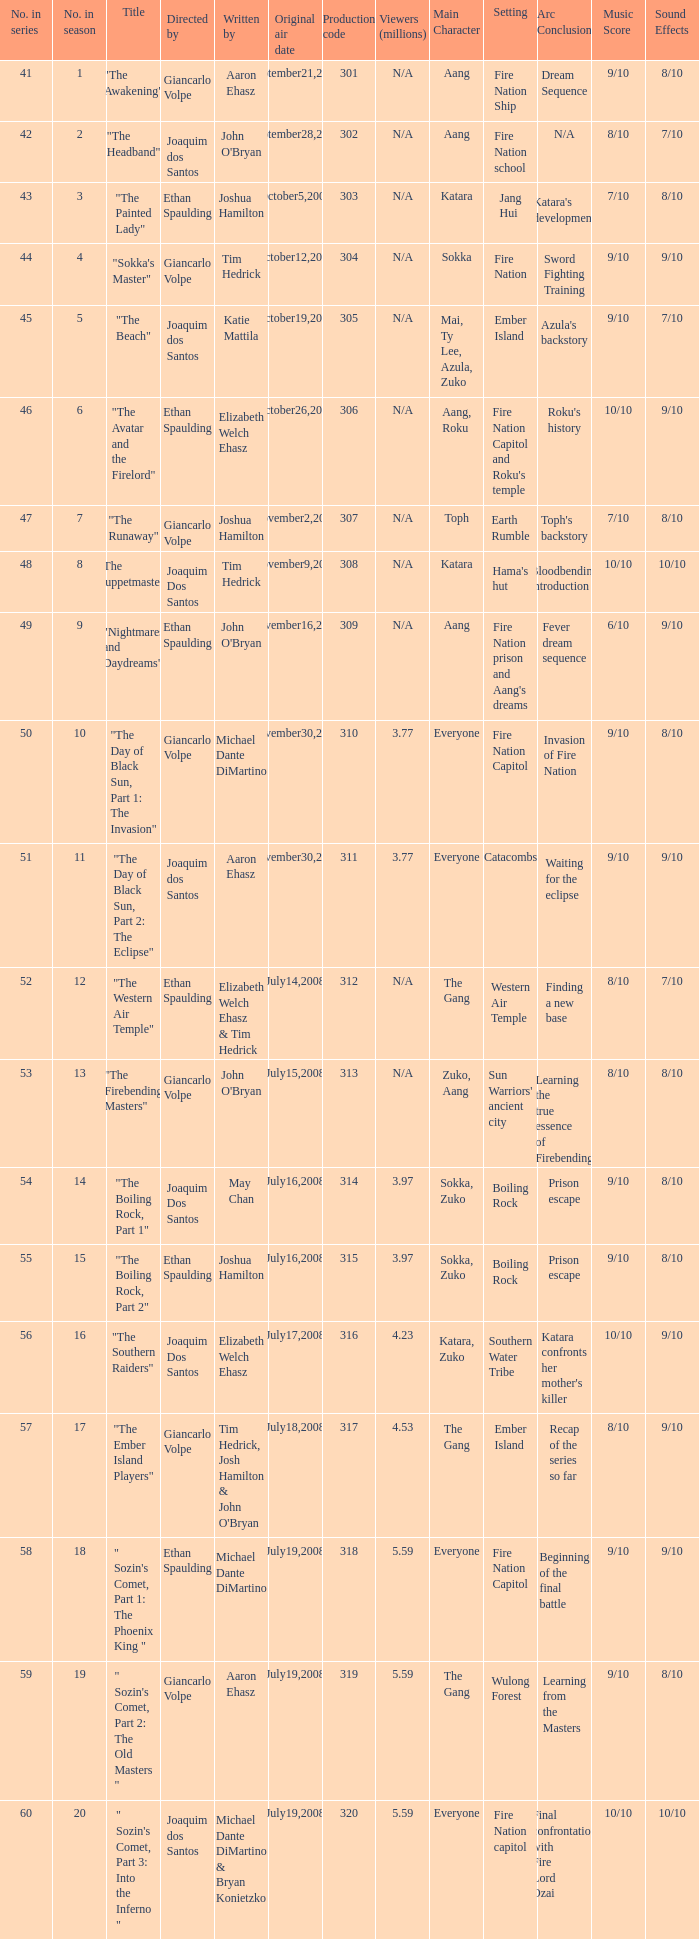What are all the numbers in the series with an episode title of "the beach"? 45.0. 